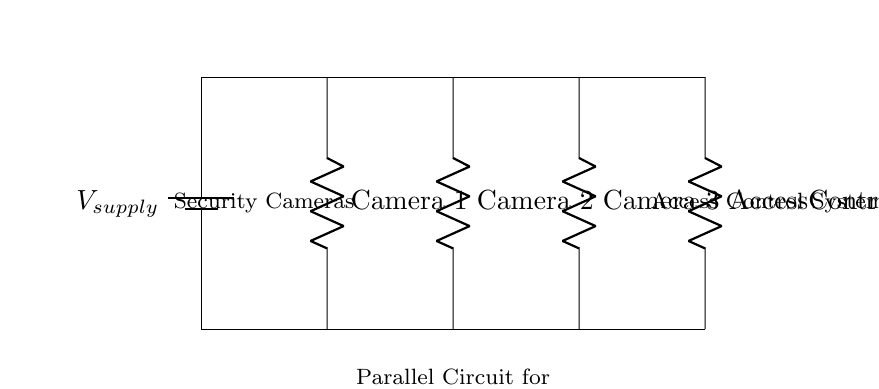What is the type of circuit represented? The circuit shown is a parallel circuit, as indicated by the multiple paths for current to flow from the voltage supply to each component. Each component is connected directly across the supply voltage.
Answer: Parallel circuit How many security cameras are connected? The circuit diagram shows three security cameras connected in parallel, each represented by a resistor symbol with the corresponding labels.
Answer: Three What is the function of the access control system in this circuit? The access control system acts as another component in the parallel circuit, providing an additional branch through which the supply voltage is distributed. It operates independently of the security cameras within the circuit structure.
Answer: Access control system What is the significance of a parallel configuration for this application? A parallel configuration is important for this application because it allows each security camera and the access control system to operate independently, ensuring that if one component fails, the others remain functional. This enhances system reliability and security.
Answer: Reliability What voltage would each camera receive? In a parallel circuit, all components receive the same voltage from the supply source. Thus, each camera receives the supply voltage, which is consistent among all parallel branches.
Answer: Supply voltage 